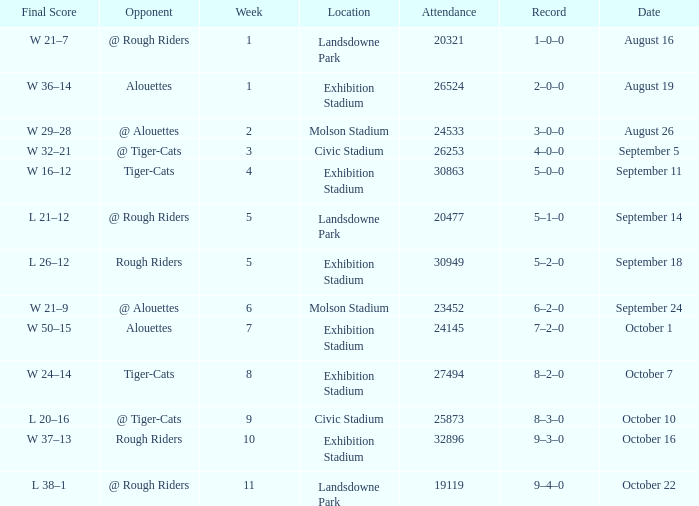How many values for attendance on the date of September 5? 1.0. 